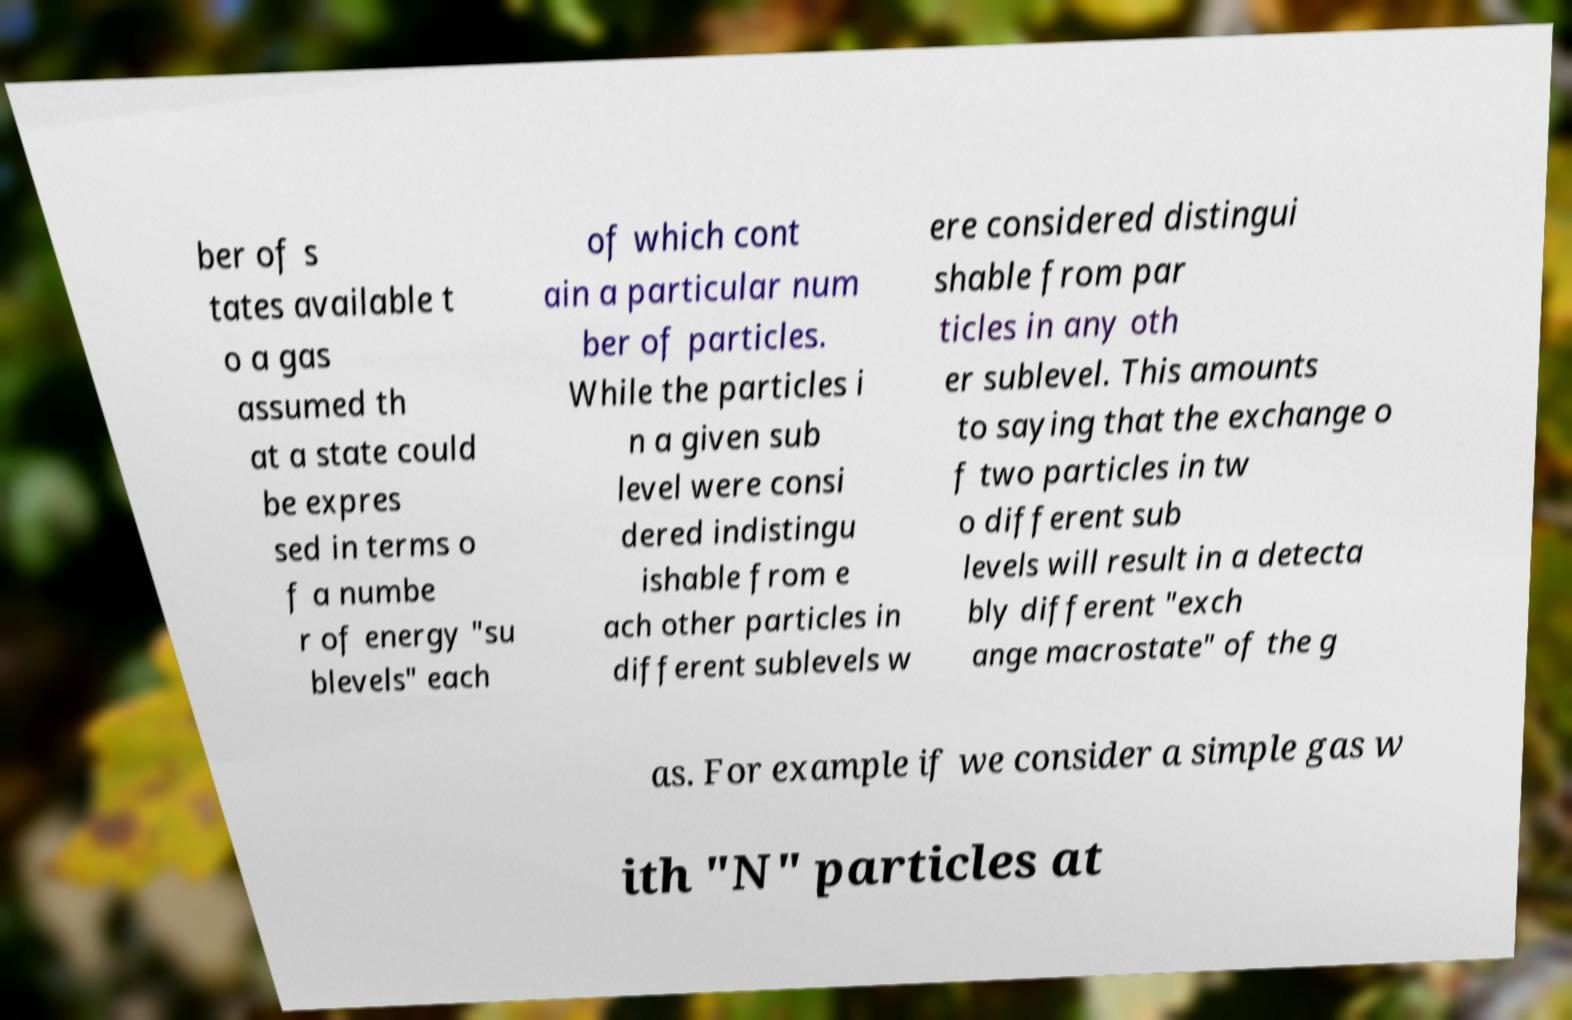Can you accurately transcribe the text from the provided image for me? ber of s tates available t o a gas assumed th at a state could be expres sed in terms o f a numbe r of energy "su blevels" each of which cont ain a particular num ber of particles. While the particles i n a given sub level were consi dered indistingu ishable from e ach other particles in different sublevels w ere considered distingui shable from par ticles in any oth er sublevel. This amounts to saying that the exchange o f two particles in tw o different sub levels will result in a detecta bly different "exch ange macrostate" of the g as. For example if we consider a simple gas w ith "N" particles at 